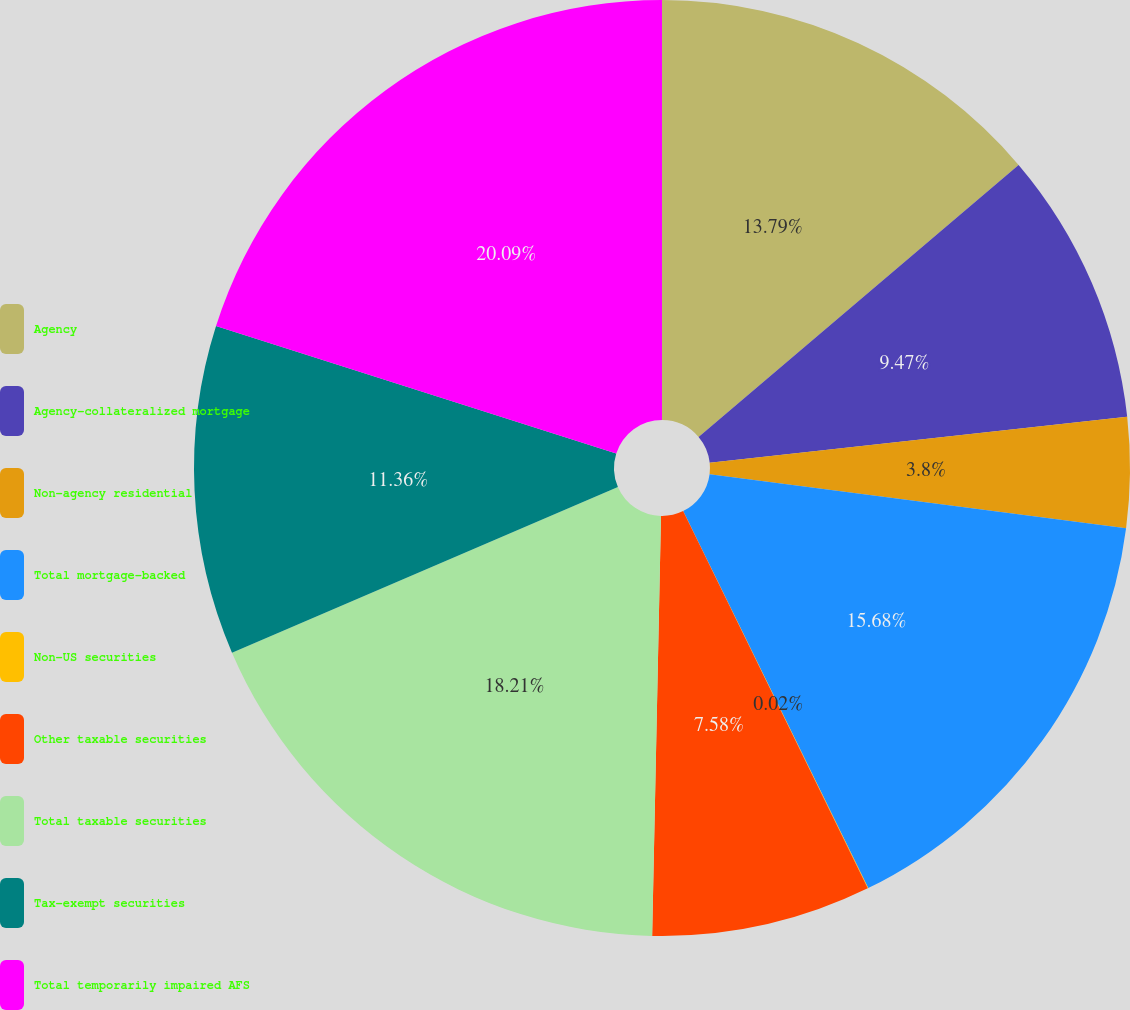Convert chart. <chart><loc_0><loc_0><loc_500><loc_500><pie_chart><fcel>Agency<fcel>Agency-collateralized mortgage<fcel>Non-agency residential<fcel>Total mortgage-backed<fcel>Non-US securities<fcel>Other taxable securities<fcel>Total taxable securities<fcel>Tax-exempt securities<fcel>Total temporarily impaired AFS<nl><fcel>13.79%<fcel>9.47%<fcel>3.8%<fcel>15.68%<fcel>0.02%<fcel>7.58%<fcel>18.21%<fcel>11.36%<fcel>20.1%<nl></chart> 